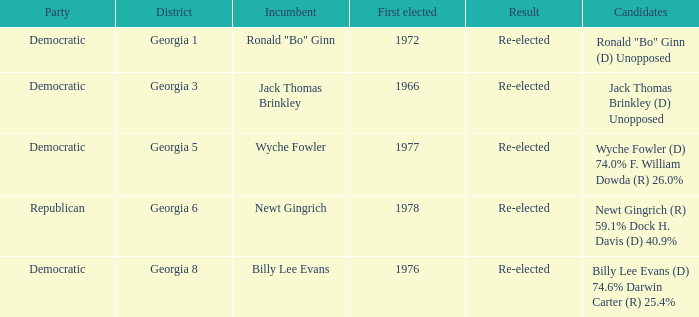What is the earliest first elected for district georgia 1? 1972.0. 